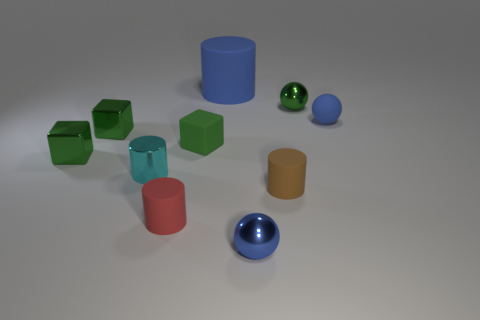How many tiny shiny balls are behind the tiny matte cylinder that is on the right side of the green block that is to the right of the cyan object?
Your answer should be very brief. 1. There is a tiny rubber sphere; is its color the same as the small rubber thing that is on the left side of the tiny green matte block?
Offer a terse response. No. What is the size of the other red cylinder that is made of the same material as the big cylinder?
Keep it short and to the point. Small. Are there more red cylinders behind the small brown thing than brown rubber cylinders?
Ensure brevity in your answer.  No. There is a small blue ball that is behind the tiny cylinder left of the tiny rubber cylinder left of the large blue rubber thing; what is its material?
Ensure brevity in your answer.  Rubber. Does the small brown cylinder have the same material as the green block right of the small red cylinder?
Provide a succinct answer. Yes. There is a big blue thing that is the same shape as the small cyan metallic thing; what is it made of?
Your answer should be very brief. Rubber. Are there any other things that have the same material as the red cylinder?
Provide a short and direct response. Yes. Is the number of large rubber cylinders that are on the left side of the big rubber thing greater than the number of balls in front of the shiny cylinder?
Offer a very short reply. No. There is a tiny cyan object that is made of the same material as the green sphere; what is its shape?
Keep it short and to the point. Cylinder. 